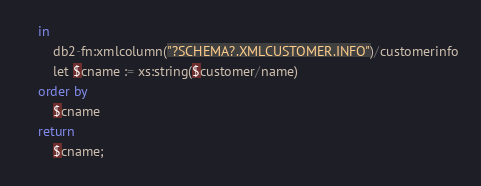<code> <loc_0><loc_0><loc_500><loc_500><_SQL_>    in
        db2-fn:xmlcolumn("?SCHEMA?.XMLCUSTOMER.INFO")/customerinfo
        let $cname := xs:string($customer/name)
    order by
        $cname
    return
        $cname;
</code> 